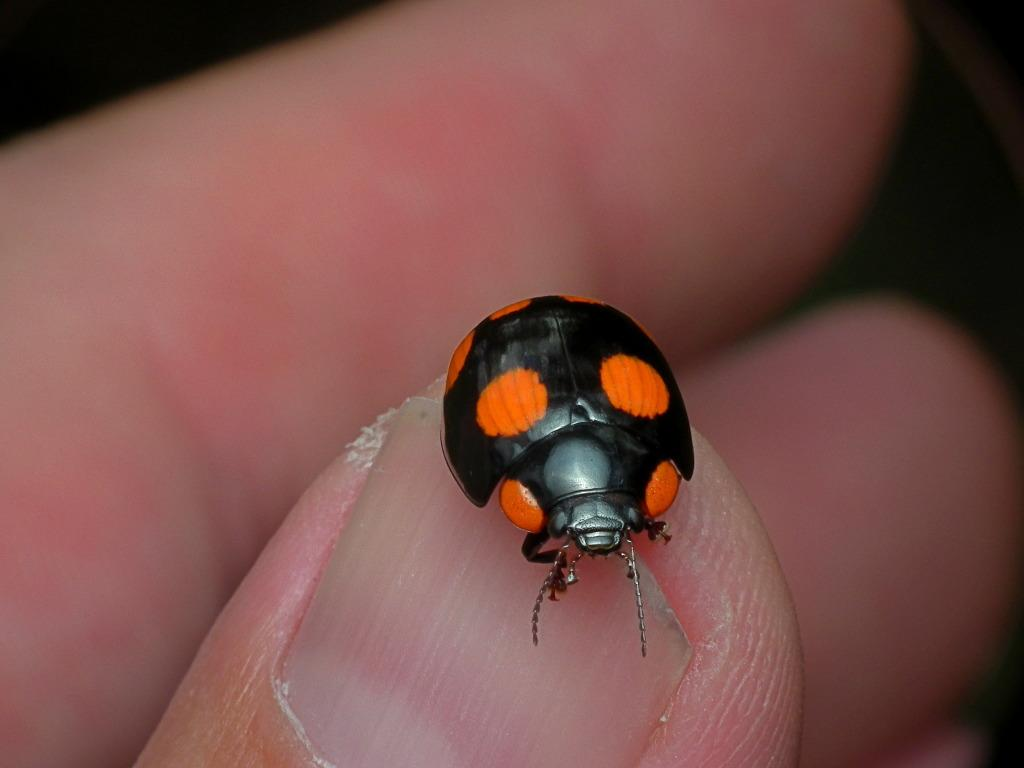What part of a person is visible in the image? There is a person's hand in the image. What is present on one of the fingers in the image? There is an insect on one of the fingers in the image. What can be said about the color of the insect? The insect is black in color. What type of friction is the insect experiencing on the finger in the image? The image does not provide information about the type of friction the insect is experiencing on the finger. 